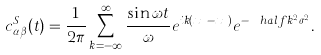<formula> <loc_0><loc_0><loc_500><loc_500>c ^ { S } _ { \alpha \beta } ( t ) = \frac { 1 } { 2 \pi } \sum _ { k = - \infty } ^ { \infty } \frac { \sin \omega t } { \omega } e ^ { i k ( x _ { \alpha } - x _ { \beta } ) } e ^ { - \ h a l f k ^ { 2 } \sigma ^ { 2 } } .</formula> 